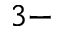Convert formula to latex. <formula><loc_0><loc_0><loc_500><loc_500>3 -</formula> 